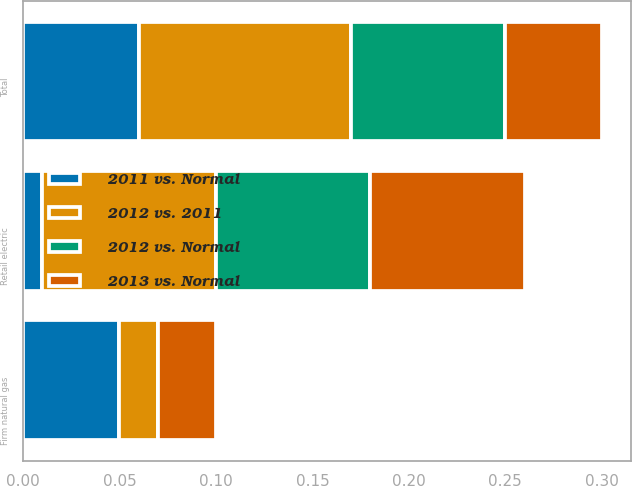Convert chart. <chart><loc_0><loc_0><loc_500><loc_500><stacked_bar_chart><ecel><fcel>Retail electric<fcel>Firm natural gas<fcel>Total<nl><fcel>2012 vs. 2011<fcel>0.09<fcel>0.02<fcel>0.11<nl><fcel>2013 vs. Normal<fcel>0.08<fcel>0.03<fcel>0.05<nl><fcel>2011 vs. Normal<fcel>0.01<fcel>0.05<fcel>0.06<nl><fcel>2012 vs. Normal<fcel>0.08<fcel>0<fcel>0.08<nl></chart> 